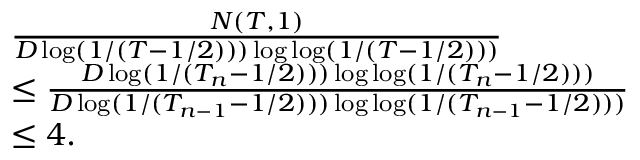Convert formula to latex. <formula><loc_0><loc_0><loc_500><loc_500>\begin{array} { r l } & { \frac { N ( T , 1 ) } { D \log ( 1 / ( T - 1 / 2 ) ) ) \log \log ( 1 / ( T - 1 / 2 ) ) ) } } \\ & { \leq \frac { D \log ( 1 / ( T _ { n } - 1 / 2 ) ) ) \log \log ( 1 / ( T _ { n } - 1 / 2 ) ) ) } { D \log ( 1 / ( T _ { n - 1 } - 1 / 2 ) ) ) \log \log ( 1 / ( T _ { n - 1 } - 1 / 2 ) ) ) } } \\ & { \leq 4 . } \end{array}</formula> 